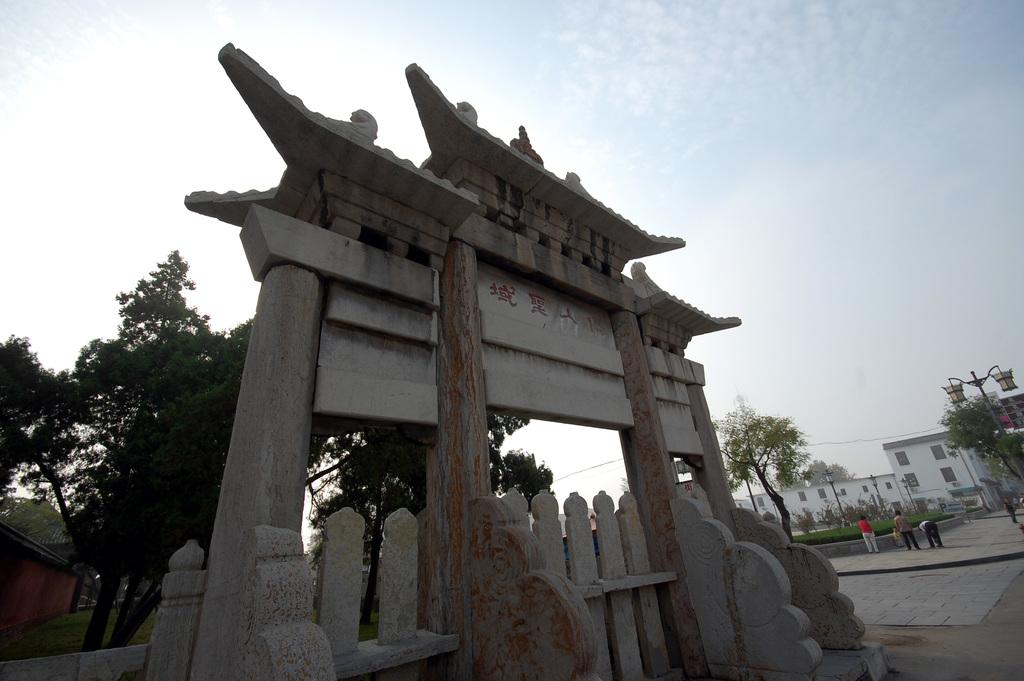What types of living organisms can be seen in the image? People, trees, and plants are visible in the image. What types of structures are present in the image? Buildings and poles are present in the image. What is visible on the ground in the image? Grass is visible on the ground in the image. What is visible in the sky in the image? The sky is visible in the image. What else can be seen on the ground in the image? The ground is visible in the image. How many centimeters of love can be measured in the image? Love is not a physical or measurable entity, so it cannot be measured in centimeters in the image. Is there a dog visible in the image? No, there is no dog present in the image. 